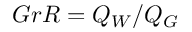Convert formula to latex. <formula><loc_0><loc_0><loc_500><loc_500>G r R = Q _ { W } / Q _ { G }</formula> 